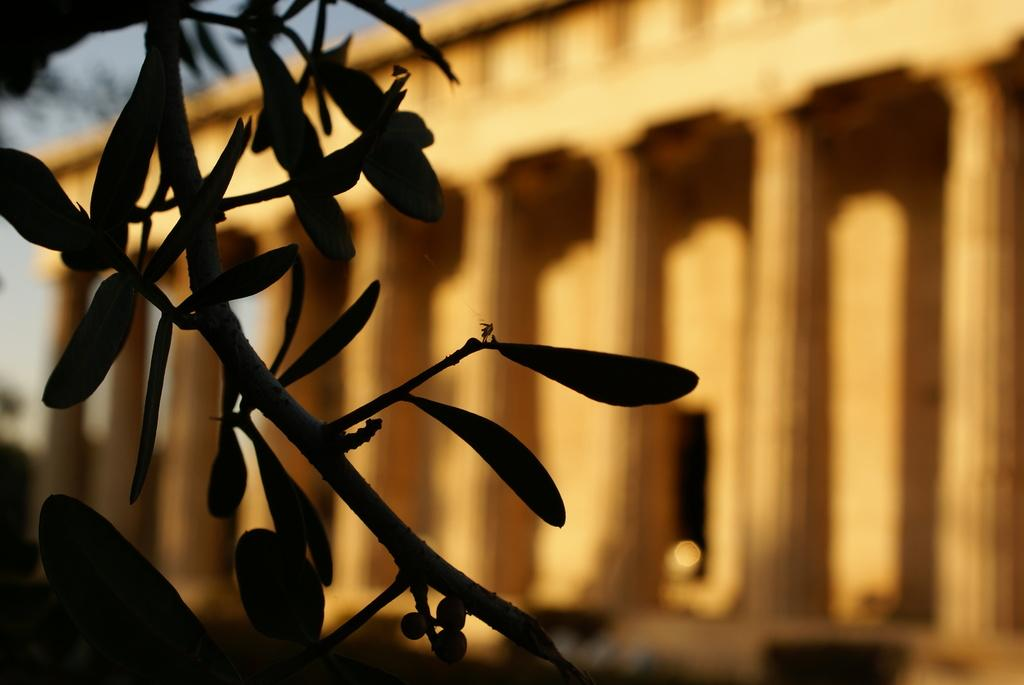What is located in the foreground of the image? There is a stem with leaves in the foreground of the image. What can be seen in the background of the image? There is a building in the background of the image. What type of judgment is the judge making in the image? There is no judge present in the image, so it is not possible to determine what judgment might be made. 